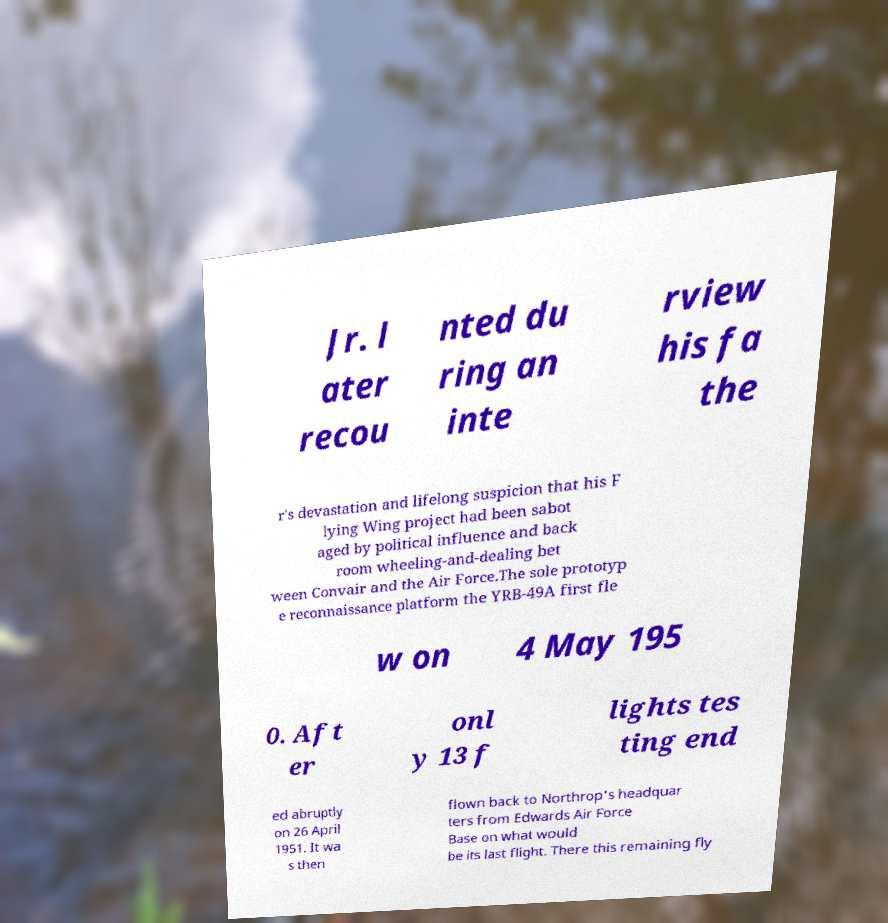Can you accurately transcribe the text from the provided image for me? Jr. l ater recou nted du ring an inte rview his fa the r's devastation and lifelong suspicion that his F lying Wing project had been sabot aged by political influence and back room wheeling-and-dealing bet ween Convair and the Air Force.The sole prototyp e reconnaissance platform the YRB-49A first fle w on 4 May 195 0. Aft er onl y 13 f lights tes ting end ed abruptly on 26 April 1951. It wa s then flown back to Northrop's headquar ters from Edwards Air Force Base on what would be its last flight. There this remaining fly 